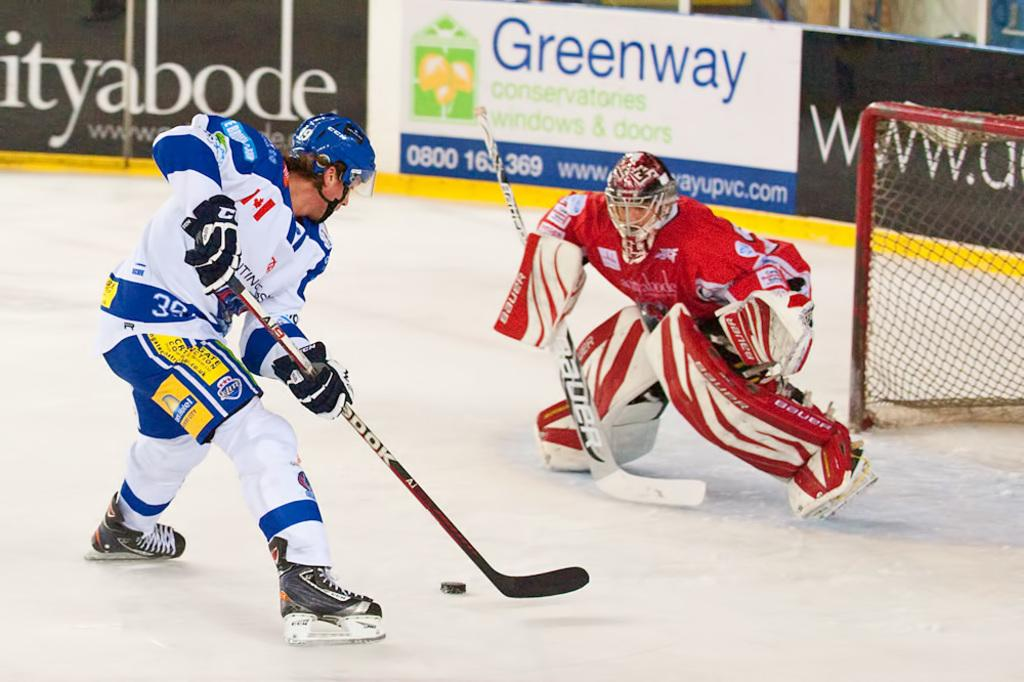<image>
Summarize the visual content of the image. A Greenway conservatories ad sponsors a hockey game. 